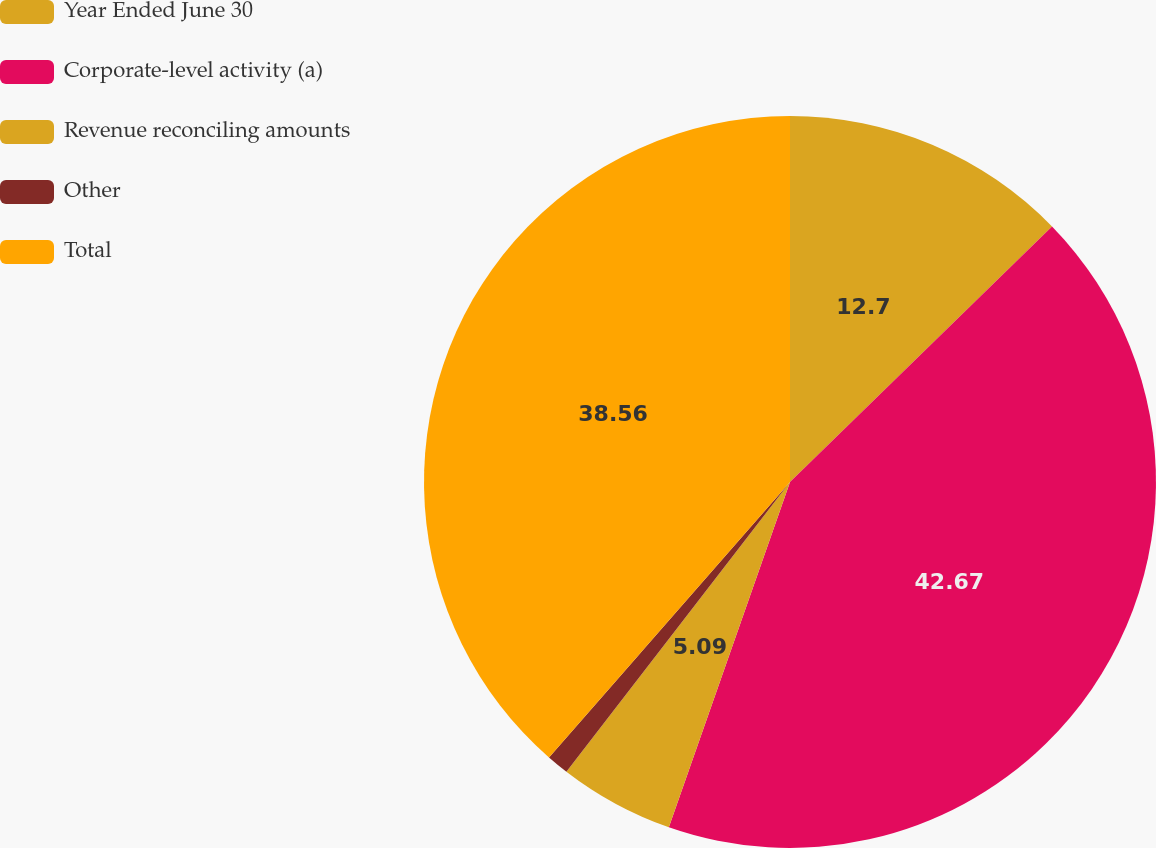<chart> <loc_0><loc_0><loc_500><loc_500><pie_chart><fcel>Year Ended June 30<fcel>Corporate-level activity (a)<fcel>Revenue reconciling amounts<fcel>Other<fcel>Total<nl><fcel>12.7%<fcel>42.67%<fcel>5.09%<fcel>0.98%<fcel>38.56%<nl></chart> 